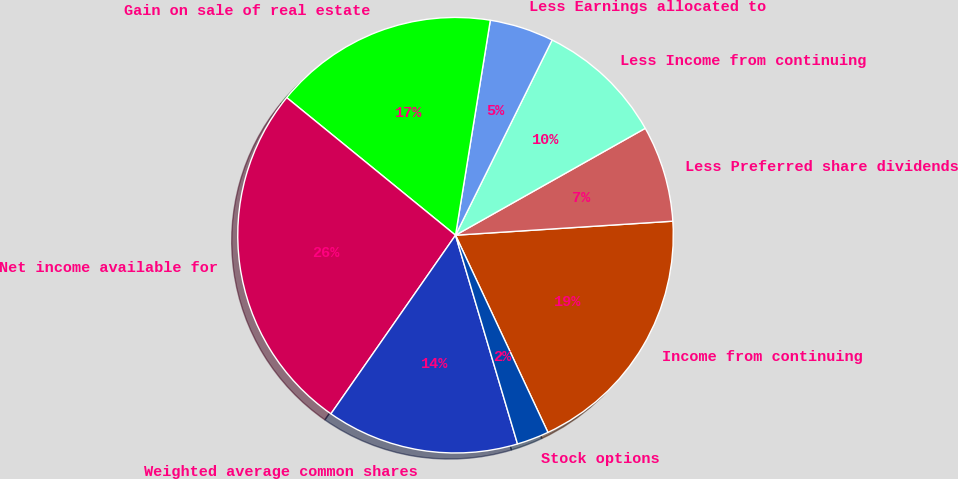Convert chart. <chart><loc_0><loc_0><loc_500><loc_500><pie_chart><fcel>Income from continuing<fcel>Less Preferred share dividends<fcel>Less Income from continuing<fcel>Less Earnings allocated to<fcel>Gain on sale of real estate<fcel>Net income available for<fcel>Weighted average common shares<fcel>Stock options<nl><fcel>19.05%<fcel>7.14%<fcel>9.52%<fcel>4.76%<fcel>16.67%<fcel>26.19%<fcel>14.29%<fcel>2.38%<nl></chart> 